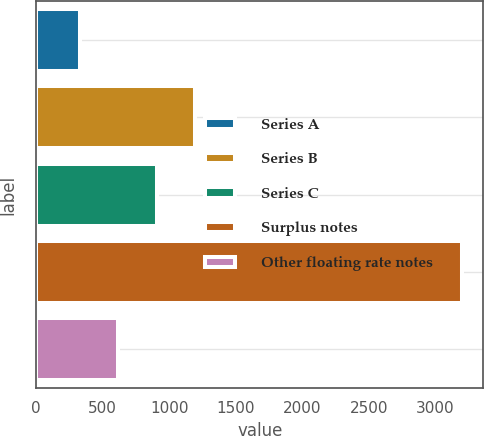Convert chart to OTSL. <chart><loc_0><loc_0><loc_500><loc_500><bar_chart><fcel>Series A<fcel>Series B<fcel>Series C<fcel>Surplus notes<fcel>Other floating rate notes<nl><fcel>333<fcel>1193.1<fcel>906.4<fcel>3200<fcel>619.7<nl></chart> 